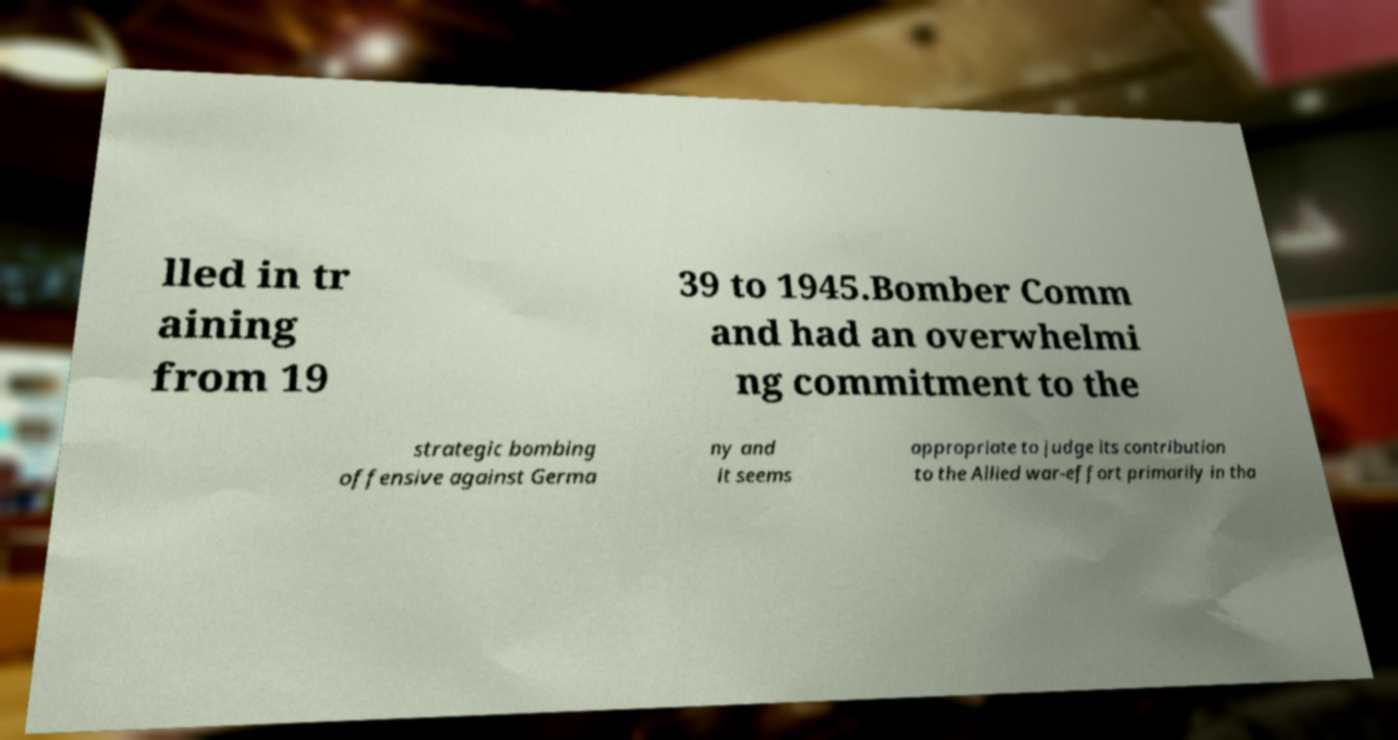Please identify and transcribe the text found in this image. lled in tr aining from 19 39 to 1945.Bomber Comm and had an overwhelmi ng commitment to the strategic bombing offensive against Germa ny and it seems appropriate to judge its contribution to the Allied war-effort primarily in tha 